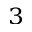Convert formula to latex. <formula><loc_0><loc_0><loc_500><loc_500>^ { 3 }</formula> 